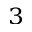Convert formula to latex. <formula><loc_0><loc_0><loc_500><loc_500>^ { 3 }</formula> 